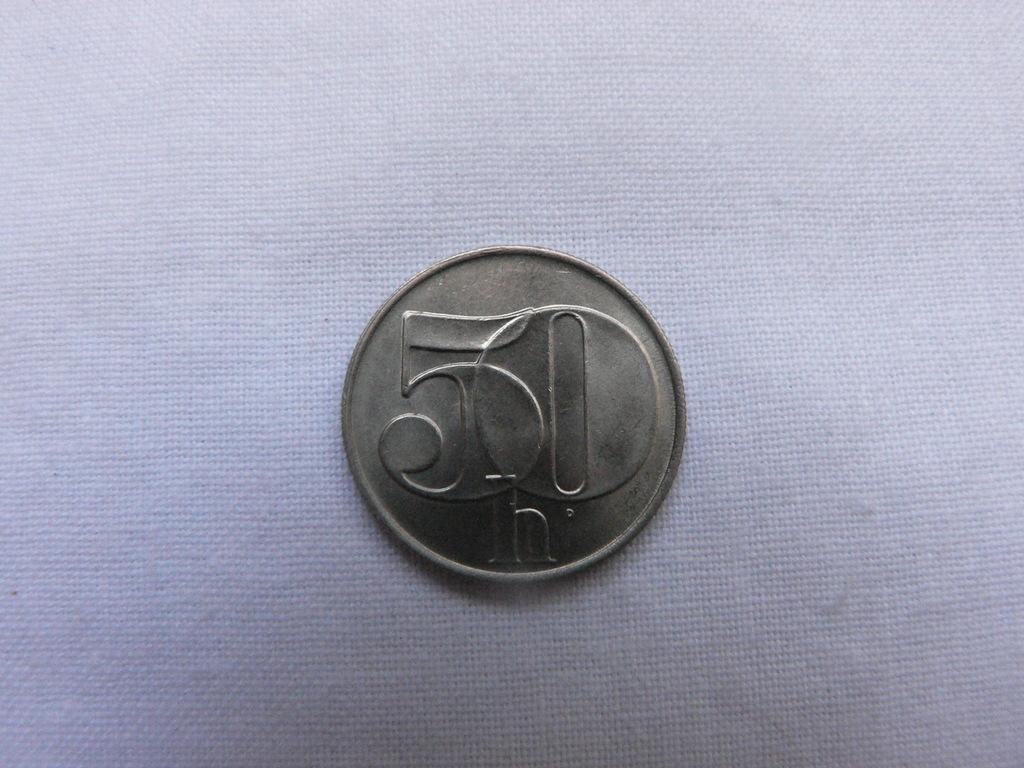<image>
Relay a brief, clear account of the picture shown. A coin with the number 50 on it is alone on a table 